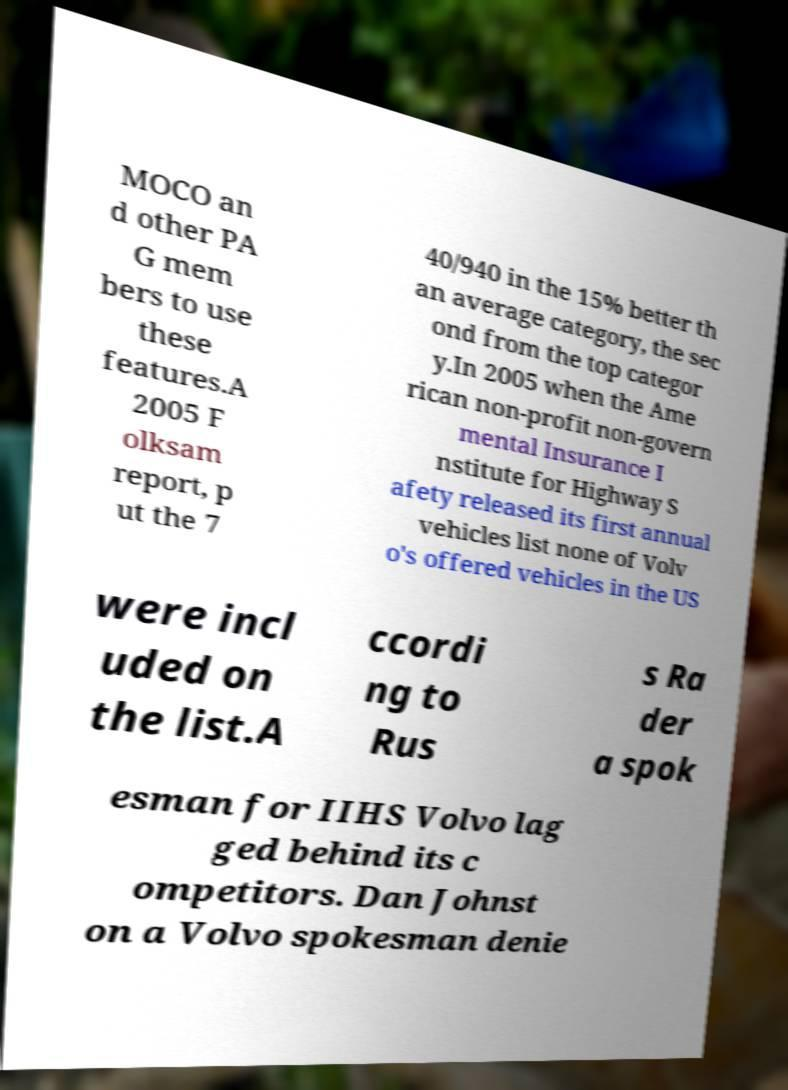Can you read and provide the text displayed in the image?This photo seems to have some interesting text. Can you extract and type it out for me? MOCO an d other PA G mem bers to use these features.A 2005 F olksam report, p ut the 7 40/940 in the 15% better th an average category, the sec ond from the top categor y.In 2005 when the Ame rican non-profit non-govern mental Insurance I nstitute for Highway S afety released its first annual vehicles list none of Volv o's offered vehicles in the US were incl uded on the list.A ccordi ng to Rus s Ra der a spok esman for IIHS Volvo lag ged behind its c ompetitors. Dan Johnst on a Volvo spokesman denie 